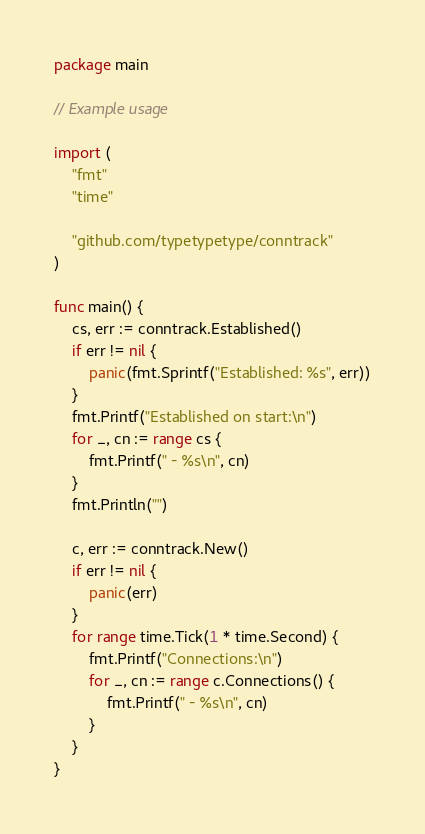Convert code to text. <code><loc_0><loc_0><loc_500><loc_500><_Go_>package main

// Example usage

import (
	"fmt"
	"time"

	"github.com/typetypetype/conntrack"
)

func main() {
	cs, err := conntrack.Established()
	if err != nil {
		panic(fmt.Sprintf("Established: %s", err))
	}
	fmt.Printf("Established on start:\n")
	for _, cn := range cs {
		fmt.Printf(" - %s\n", cn)
	}
	fmt.Println("")

	c, err := conntrack.New()
	if err != nil {
		panic(err)
	}
	for range time.Tick(1 * time.Second) {
		fmt.Printf("Connections:\n")
		for _, cn := range c.Connections() {
			fmt.Printf(" - %s\n", cn)
		}
	}
}
</code> 